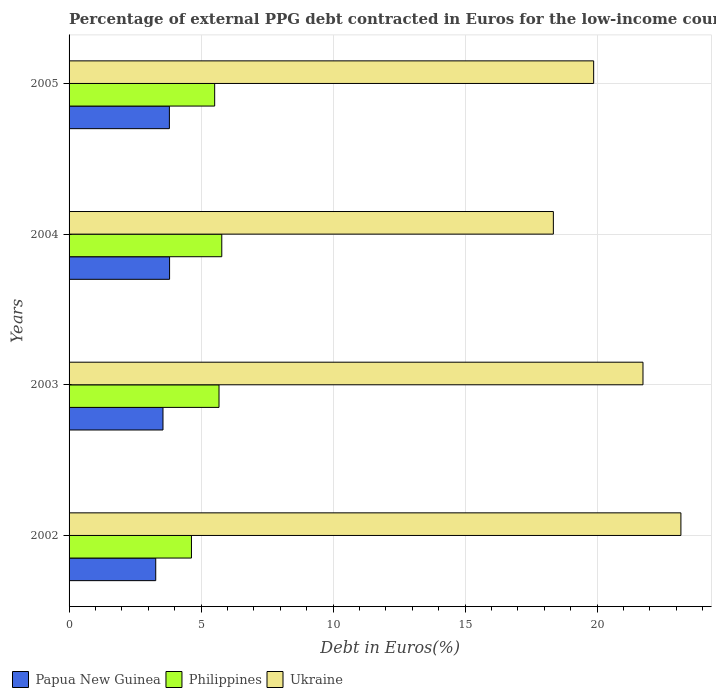How many different coloured bars are there?
Ensure brevity in your answer.  3. How many groups of bars are there?
Your response must be concise. 4. How many bars are there on the 4th tick from the top?
Your answer should be compact. 3. What is the label of the 4th group of bars from the top?
Provide a succinct answer. 2002. In how many cases, is the number of bars for a given year not equal to the number of legend labels?
Provide a succinct answer. 0. What is the percentage of external PPG debt contracted in Euros in Ukraine in 2002?
Keep it short and to the point. 23.18. Across all years, what is the maximum percentage of external PPG debt contracted in Euros in Papua New Guinea?
Keep it short and to the point. 3.81. Across all years, what is the minimum percentage of external PPG debt contracted in Euros in Philippines?
Your answer should be very brief. 4.64. In which year was the percentage of external PPG debt contracted in Euros in Philippines minimum?
Provide a short and direct response. 2002. What is the total percentage of external PPG debt contracted in Euros in Philippines in the graph?
Give a very brief answer. 21.62. What is the difference between the percentage of external PPG debt contracted in Euros in Philippines in 2003 and that in 2004?
Your answer should be compact. -0.1. What is the difference between the percentage of external PPG debt contracted in Euros in Philippines in 2005 and the percentage of external PPG debt contracted in Euros in Papua New Guinea in 2003?
Your response must be concise. 1.96. What is the average percentage of external PPG debt contracted in Euros in Ukraine per year?
Your answer should be compact. 20.79. In the year 2003, what is the difference between the percentage of external PPG debt contracted in Euros in Ukraine and percentage of external PPG debt contracted in Euros in Papua New Guinea?
Ensure brevity in your answer.  18.18. In how many years, is the percentage of external PPG debt contracted in Euros in Ukraine greater than 5 %?
Provide a short and direct response. 4. What is the ratio of the percentage of external PPG debt contracted in Euros in Papua New Guinea in 2002 to that in 2004?
Provide a succinct answer. 0.86. What is the difference between the highest and the second highest percentage of external PPG debt contracted in Euros in Philippines?
Your answer should be very brief. 0.1. What is the difference between the highest and the lowest percentage of external PPG debt contracted in Euros in Papua New Guinea?
Keep it short and to the point. 0.52. What does the 1st bar from the bottom in 2003 represents?
Keep it short and to the point. Papua New Guinea. Is it the case that in every year, the sum of the percentage of external PPG debt contracted in Euros in Ukraine and percentage of external PPG debt contracted in Euros in Philippines is greater than the percentage of external PPG debt contracted in Euros in Papua New Guinea?
Your answer should be very brief. Yes. Does the graph contain any zero values?
Provide a short and direct response. No. Where does the legend appear in the graph?
Keep it short and to the point. Bottom left. How many legend labels are there?
Your answer should be compact. 3. How are the legend labels stacked?
Your answer should be very brief. Horizontal. What is the title of the graph?
Make the answer very short. Percentage of external PPG debt contracted in Euros for the low-income countries. What is the label or title of the X-axis?
Make the answer very short. Debt in Euros(%). What is the Debt in Euros(%) in Papua New Guinea in 2002?
Provide a short and direct response. 3.28. What is the Debt in Euros(%) of Philippines in 2002?
Keep it short and to the point. 4.64. What is the Debt in Euros(%) of Ukraine in 2002?
Give a very brief answer. 23.18. What is the Debt in Euros(%) in Papua New Guinea in 2003?
Keep it short and to the point. 3.56. What is the Debt in Euros(%) of Philippines in 2003?
Your answer should be compact. 5.68. What is the Debt in Euros(%) in Ukraine in 2003?
Ensure brevity in your answer.  21.74. What is the Debt in Euros(%) of Papua New Guinea in 2004?
Provide a succinct answer. 3.81. What is the Debt in Euros(%) of Philippines in 2004?
Offer a terse response. 5.79. What is the Debt in Euros(%) in Ukraine in 2004?
Provide a succinct answer. 18.35. What is the Debt in Euros(%) of Papua New Guinea in 2005?
Offer a terse response. 3.8. What is the Debt in Euros(%) in Philippines in 2005?
Give a very brief answer. 5.52. What is the Debt in Euros(%) in Ukraine in 2005?
Ensure brevity in your answer.  19.87. Across all years, what is the maximum Debt in Euros(%) in Papua New Guinea?
Make the answer very short. 3.81. Across all years, what is the maximum Debt in Euros(%) of Philippines?
Your answer should be compact. 5.79. Across all years, what is the maximum Debt in Euros(%) of Ukraine?
Your response must be concise. 23.18. Across all years, what is the minimum Debt in Euros(%) of Papua New Guinea?
Make the answer very short. 3.28. Across all years, what is the minimum Debt in Euros(%) of Philippines?
Keep it short and to the point. 4.64. Across all years, what is the minimum Debt in Euros(%) of Ukraine?
Keep it short and to the point. 18.35. What is the total Debt in Euros(%) of Papua New Guinea in the graph?
Your answer should be compact. 14.45. What is the total Debt in Euros(%) of Philippines in the graph?
Your answer should be very brief. 21.62. What is the total Debt in Euros(%) in Ukraine in the graph?
Keep it short and to the point. 83.14. What is the difference between the Debt in Euros(%) of Papua New Guinea in 2002 and that in 2003?
Provide a succinct answer. -0.27. What is the difference between the Debt in Euros(%) of Philippines in 2002 and that in 2003?
Provide a succinct answer. -1.04. What is the difference between the Debt in Euros(%) in Ukraine in 2002 and that in 2003?
Offer a very short reply. 1.44. What is the difference between the Debt in Euros(%) in Papua New Guinea in 2002 and that in 2004?
Your answer should be compact. -0.53. What is the difference between the Debt in Euros(%) in Philippines in 2002 and that in 2004?
Make the answer very short. -1.15. What is the difference between the Debt in Euros(%) of Ukraine in 2002 and that in 2004?
Give a very brief answer. 4.83. What is the difference between the Debt in Euros(%) of Papua New Guinea in 2002 and that in 2005?
Your response must be concise. -0.52. What is the difference between the Debt in Euros(%) of Philippines in 2002 and that in 2005?
Give a very brief answer. -0.88. What is the difference between the Debt in Euros(%) of Ukraine in 2002 and that in 2005?
Provide a succinct answer. 3.31. What is the difference between the Debt in Euros(%) in Papua New Guinea in 2003 and that in 2004?
Your answer should be compact. -0.25. What is the difference between the Debt in Euros(%) of Philippines in 2003 and that in 2004?
Your response must be concise. -0.1. What is the difference between the Debt in Euros(%) in Ukraine in 2003 and that in 2004?
Offer a very short reply. 3.4. What is the difference between the Debt in Euros(%) of Papua New Guinea in 2003 and that in 2005?
Your answer should be very brief. -0.24. What is the difference between the Debt in Euros(%) of Philippines in 2003 and that in 2005?
Make the answer very short. 0.16. What is the difference between the Debt in Euros(%) of Ukraine in 2003 and that in 2005?
Offer a terse response. 1.87. What is the difference between the Debt in Euros(%) in Papua New Guinea in 2004 and that in 2005?
Make the answer very short. 0.01. What is the difference between the Debt in Euros(%) in Philippines in 2004 and that in 2005?
Ensure brevity in your answer.  0.27. What is the difference between the Debt in Euros(%) in Ukraine in 2004 and that in 2005?
Your response must be concise. -1.53. What is the difference between the Debt in Euros(%) in Papua New Guinea in 2002 and the Debt in Euros(%) in Philippines in 2003?
Your response must be concise. -2.4. What is the difference between the Debt in Euros(%) in Papua New Guinea in 2002 and the Debt in Euros(%) in Ukraine in 2003?
Give a very brief answer. -18.46. What is the difference between the Debt in Euros(%) of Philippines in 2002 and the Debt in Euros(%) of Ukraine in 2003?
Make the answer very short. -17.11. What is the difference between the Debt in Euros(%) in Papua New Guinea in 2002 and the Debt in Euros(%) in Philippines in 2004?
Your answer should be compact. -2.5. What is the difference between the Debt in Euros(%) in Papua New Guinea in 2002 and the Debt in Euros(%) in Ukraine in 2004?
Provide a short and direct response. -15.06. What is the difference between the Debt in Euros(%) in Philippines in 2002 and the Debt in Euros(%) in Ukraine in 2004?
Offer a very short reply. -13.71. What is the difference between the Debt in Euros(%) in Papua New Guinea in 2002 and the Debt in Euros(%) in Philippines in 2005?
Your answer should be compact. -2.23. What is the difference between the Debt in Euros(%) in Papua New Guinea in 2002 and the Debt in Euros(%) in Ukraine in 2005?
Your response must be concise. -16.59. What is the difference between the Debt in Euros(%) of Philippines in 2002 and the Debt in Euros(%) of Ukraine in 2005?
Provide a succinct answer. -15.24. What is the difference between the Debt in Euros(%) in Papua New Guinea in 2003 and the Debt in Euros(%) in Philippines in 2004?
Keep it short and to the point. -2.23. What is the difference between the Debt in Euros(%) in Papua New Guinea in 2003 and the Debt in Euros(%) in Ukraine in 2004?
Offer a terse response. -14.79. What is the difference between the Debt in Euros(%) in Philippines in 2003 and the Debt in Euros(%) in Ukraine in 2004?
Provide a short and direct response. -12.67. What is the difference between the Debt in Euros(%) in Papua New Guinea in 2003 and the Debt in Euros(%) in Philippines in 2005?
Your response must be concise. -1.96. What is the difference between the Debt in Euros(%) of Papua New Guinea in 2003 and the Debt in Euros(%) of Ukraine in 2005?
Provide a short and direct response. -16.32. What is the difference between the Debt in Euros(%) in Philippines in 2003 and the Debt in Euros(%) in Ukraine in 2005?
Your answer should be compact. -14.19. What is the difference between the Debt in Euros(%) in Papua New Guinea in 2004 and the Debt in Euros(%) in Philippines in 2005?
Ensure brevity in your answer.  -1.71. What is the difference between the Debt in Euros(%) in Papua New Guinea in 2004 and the Debt in Euros(%) in Ukraine in 2005?
Offer a very short reply. -16.07. What is the difference between the Debt in Euros(%) of Philippines in 2004 and the Debt in Euros(%) of Ukraine in 2005?
Your answer should be compact. -14.09. What is the average Debt in Euros(%) of Papua New Guinea per year?
Provide a short and direct response. 3.61. What is the average Debt in Euros(%) in Philippines per year?
Offer a very short reply. 5.4. What is the average Debt in Euros(%) in Ukraine per year?
Give a very brief answer. 20.79. In the year 2002, what is the difference between the Debt in Euros(%) of Papua New Guinea and Debt in Euros(%) of Philippines?
Offer a terse response. -1.35. In the year 2002, what is the difference between the Debt in Euros(%) of Papua New Guinea and Debt in Euros(%) of Ukraine?
Provide a succinct answer. -19.9. In the year 2002, what is the difference between the Debt in Euros(%) in Philippines and Debt in Euros(%) in Ukraine?
Provide a short and direct response. -18.54. In the year 2003, what is the difference between the Debt in Euros(%) in Papua New Guinea and Debt in Euros(%) in Philippines?
Your response must be concise. -2.12. In the year 2003, what is the difference between the Debt in Euros(%) of Papua New Guinea and Debt in Euros(%) of Ukraine?
Your response must be concise. -18.18. In the year 2003, what is the difference between the Debt in Euros(%) of Philippines and Debt in Euros(%) of Ukraine?
Make the answer very short. -16.06. In the year 2004, what is the difference between the Debt in Euros(%) in Papua New Guinea and Debt in Euros(%) in Philippines?
Offer a terse response. -1.98. In the year 2004, what is the difference between the Debt in Euros(%) in Papua New Guinea and Debt in Euros(%) in Ukraine?
Provide a succinct answer. -14.54. In the year 2004, what is the difference between the Debt in Euros(%) of Philippines and Debt in Euros(%) of Ukraine?
Provide a short and direct response. -12.56. In the year 2005, what is the difference between the Debt in Euros(%) in Papua New Guinea and Debt in Euros(%) in Philippines?
Make the answer very short. -1.72. In the year 2005, what is the difference between the Debt in Euros(%) in Papua New Guinea and Debt in Euros(%) in Ukraine?
Your answer should be very brief. -16.07. In the year 2005, what is the difference between the Debt in Euros(%) in Philippines and Debt in Euros(%) in Ukraine?
Provide a short and direct response. -14.36. What is the ratio of the Debt in Euros(%) in Papua New Guinea in 2002 to that in 2003?
Ensure brevity in your answer.  0.92. What is the ratio of the Debt in Euros(%) in Philippines in 2002 to that in 2003?
Provide a short and direct response. 0.82. What is the ratio of the Debt in Euros(%) in Ukraine in 2002 to that in 2003?
Make the answer very short. 1.07. What is the ratio of the Debt in Euros(%) in Papua New Guinea in 2002 to that in 2004?
Offer a terse response. 0.86. What is the ratio of the Debt in Euros(%) in Philippines in 2002 to that in 2004?
Keep it short and to the point. 0.8. What is the ratio of the Debt in Euros(%) of Ukraine in 2002 to that in 2004?
Your answer should be compact. 1.26. What is the ratio of the Debt in Euros(%) of Papua New Guinea in 2002 to that in 2005?
Give a very brief answer. 0.86. What is the ratio of the Debt in Euros(%) of Philippines in 2002 to that in 2005?
Make the answer very short. 0.84. What is the ratio of the Debt in Euros(%) of Ukraine in 2002 to that in 2005?
Your answer should be compact. 1.17. What is the ratio of the Debt in Euros(%) of Papua New Guinea in 2003 to that in 2004?
Keep it short and to the point. 0.93. What is the ratio of the Debt in Euros(%) in Philippines in 2003 to that in 2004?
Offer a very short reply. 0.98. What is the ratio of the Debt in Euros(%) of Ukraine in 2003 to that in 2004?
Make the answer very short. 1.19. What is the ratio of the Debt in Euros(%) of Papua New Guinea in 2003 to that in 2005?
Make the answer very short. 0.94. What is the ratio of the Debt in Euros(%) of Philippines in 2003 to that in 2005?
Your answer should be compact. 1.03. What is the ratio of the Debt in Euros(%) of Ukraine in 2003 to that in 2005?
Keep it short and to the point. 1.09. What is the ratio of the Debt in Euros(%) in Papua New Guinea in 2004 to that in 2005?
Your answer should be very brief. 1. What is the ratio of the Debt in Euros(%) in Philippines in 2004 to that in 2005?
Your answer should be compact. 1.05. What is the ratio of the Debt in Euros(%) in Ukraine in 2004 to that in 2005?
Provide a succinct answer. 0.92. What is the difference between the highest and the second highest Debt in Euros(%) in Papua New Guinea?
Offer a very short reply. 0.01. What is the difference between the highest and the second highest Debt in Euros(%) in Philippines?
Offer a very short reply. 0.1. What is the difference between the highest and the second highest Debt in Euros(%) of Ukraine?
Ensure brevity in your answer.  1.44. What is the difference between the highest and the lowest Debt in Euros(%) of Papua New Guinea?
Give a very brief answer. 0.53. What is the difference between the highest and the lowest Debt in Euros(%) of Philippines?
Keep it short and to the point. 1.15. What is the difference between the highest and the lowest Debt in Euros(%) of Ukraine?
Provide a succinct answer. 4.83. 